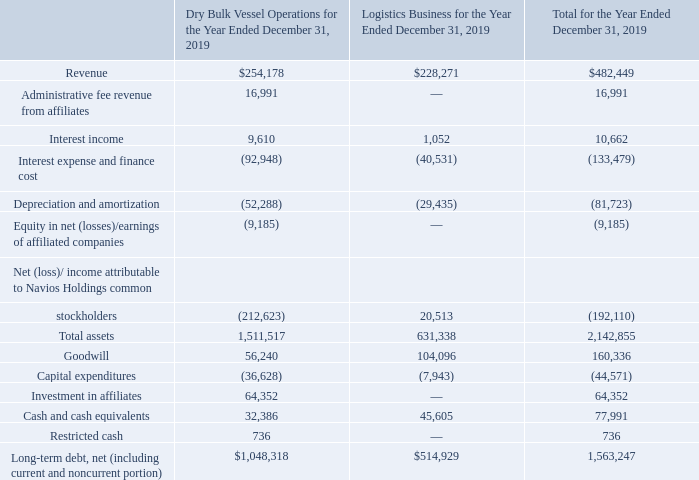NAVIOS MARITIME HOLDINGS INC. NOTES TO THE CONSOLIDATED FINANCIAL STATEMENTS (Expressed in thousands of U.S. dollars — except share data)
NOTE 19: SEGMENT INFORMATION
The Company through August 30, 2019 had three reportable segments from which it derived its revenues: Dry Bulk Vessel Operations, Logistics Business and Containers Business. The Containers Business became a reportable segment as a result of the consolidation of Navios Containers since November 30, 2018 (date of obtaining control) (see also Note 3). Following the reclassification of the results of Navios Containers as discontinued operations (see also Note 3), the Company currently has two reportable segments from which it derives its revenues: Dry Bulk Vessel Operations and Logistics. The reportable segments reflect the internal organization of the Company and are strategic businesses that offer different products and services. The Dry Bulk Vessel Operations consists of the transportation and handling of bulk cargoes through the ownership, operation, and trading of vessels. The Logistics Business consists of operating ports and transfer station terminals, handling of vessels, barges and pushboats as well as upriver transport facilities in the Hidrovia region.
The Company measures segment performance based on net income/ (loss) attributable to Navios Holdings common stockholders. Inter-segment sales and transfers are not significant and have been eliminated and are not included in the following tables. Summarized financial information concerning each of the Company’s reportable segments is as follows:
How does the company measure segment performance? Based on net income/ (loss) attributable to navios holdings common stockholders. What was the revenue for logistics business for the year?
Answer scale should be: thousand. 228,271. What was the total interest income for the year?
Answer scale should be: thousand. 10,662. What was the difference in revenue between dry bulk vessel operations and logistics business?
Answer scale should be: thousand. 254,178-228,271
Answer: 25907. What was the difference in interest income between dry bulk vessel operations and logistics business?
Answer scale should be: thousand. 9,610-1,052
Answer: 8558. What was the difference in total goodwill and total investment in affiliates?
Answer scale should be: thousand. 160,336-64,352
Answer: 95984. 